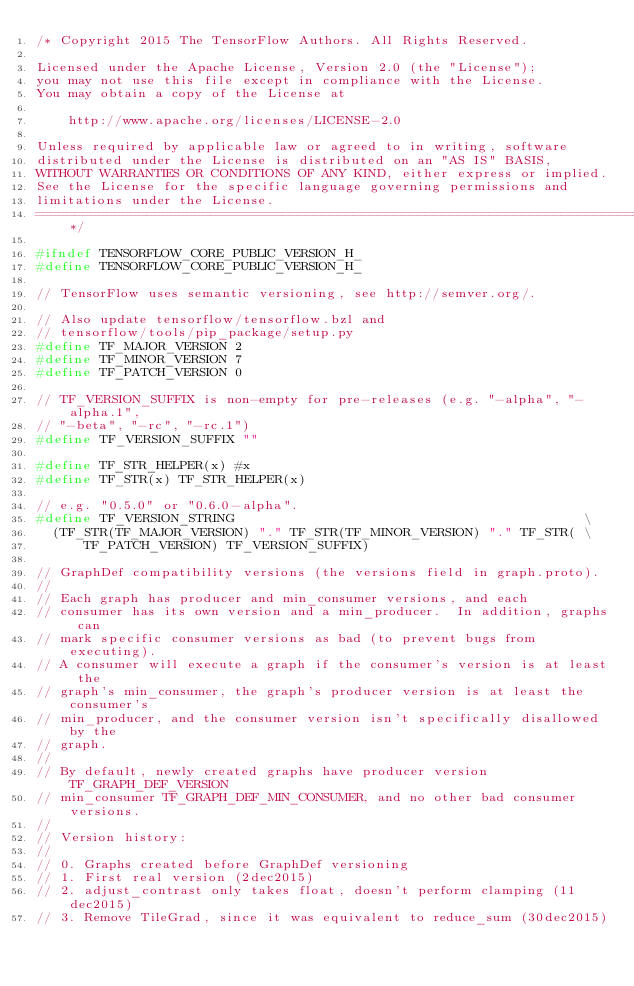Convert code to text. <code><loc_0><loc_0><loc_500><loc_500><_C_>/* Copyright 2015 The TensorFlow Authors. All Rights Reserved.

Licensed under the Apache License, Version 2.0 (the "License");
you may not use this file except in compliance with the License.
You may obtain a copy of the License at

    http://www.apache.org/licenses/LICENSE-2.0

Unless required by applicable law or agreed to in writing, software
distributed under the License is distributed on an "AS IS" BASIS,
WITHOUT WARRANTIES OR CONDITIONS OF ANY KIND, either express or implied.
See the License for the specific language governing permissions and
limitations under the License.
==============================================================================*/

#ifndef TENSORFLOW_CORE_PUBLIC_VERSION_H_
#define TENSORFLOW_CORE_PUBLIC_VERSION_H_

// TensorFlow uses semantic versioning, see http://semver.org/.

// Also update tensorflow/tensorflow.bzl and
// tensorflow/tools/pip_package/setup.py
#define TF_MAJOR_VERSION 2
#define TF_MINOR_VERSION 7
#define TF_PATCH_VERSION 0

// TF_VERSION_SUFFIX is non-empty for pre-releases (e.g. "-alpha", "-alpha.1",
// "-beta", "-rc", "-rc.1")
#define TF_VERSION_SUFFIX ""

#define TF_STR_HELPER(x) #x
#define TF_STR(x) TF_STR_HELPER(x)

// e.g. "0.5.0" or "0.6.0-alpha".
#define TF_VERSION_STRING                                            \
  (TF_STR(TF_MAJOR_VERSION) "." TF_STR(TF_MINOR_VERSION) "." TF_STR( \
      TF_PATCH_VERSION) TF_VERSION_SUFFIX)

// GraphDef compatibility versions (the versions field in graph.proto).
//
// Each graph has producer and min_consumer versions, and each
// consumer has its own version and a min_producer.  In addition, graphs can
// mark specific consumer versions as bad (to prevent bugs from executing).
// A consumer will execute a graph if the consumer's version is at least the
// graph's min_consumer, the graph's producer version is at least the consumer's
// min_producer, and the consumer version isn't specifically disallowed by the
// graph.
//
// By default, newly created graphs have producer version TF_GRAPH_DEF_VERSION
// min_consumer TF_GRAPH_DEF_MIN_CONSUMER, and no other bad consumer versions.
//
// Version history:
//
// 0. Graphs created before GraphDef versioning
// 1. First real version (2dec2015)
// 2. adjust_contrast only takes float, doesn't perform clamping (11dec2015)
// 3. Remove TileGrad, since it was equivalent to reduce_sum (30dec2015)</code> 